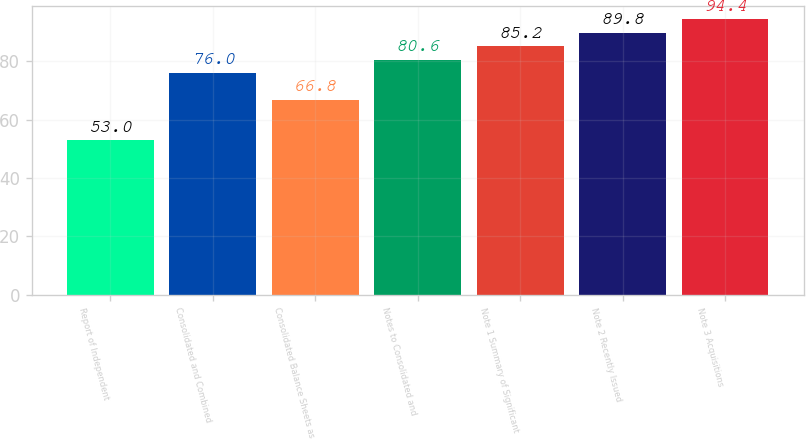<chart> <loc_0><loc_0><loc_500><loc_500><bar_chart><fcel>Report of Independent<fcel>Consolidated and Combined<fcel>Consolidated Balance Sheets as<fcel>Notes to Consolidated and<fcel>Note 1 Summary of Significant<fcel>Note 2 Recently Issued<fcel>Note 3 Acquisitions<nl><fcel>53<fcel>76<fcel>66.8<fcel>80.6<fcel>85.2<fcel>89.8<fcel>94.4<nl></chart> 